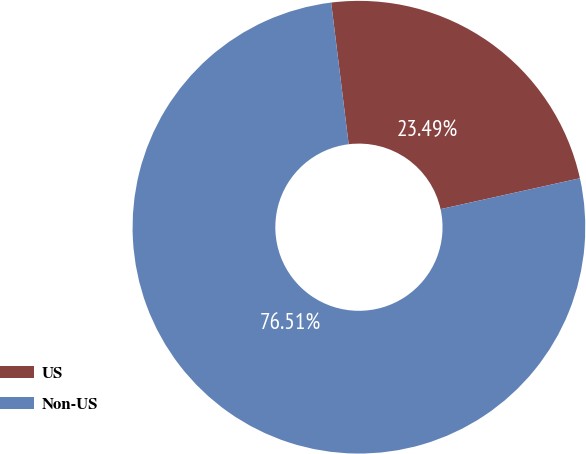Convert chart to OTSL. <chart><loc_0><loc_0><loc_500><loc_500><pie_chart><fcel>US<fcel>Non-US<nl><fcel>23.49%<fcel>76.51%<nl></chart> 